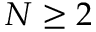Convert formula to latex. <formula><loc_0><loc_0><loc_500><loc_500>N \geq 2</formula> 